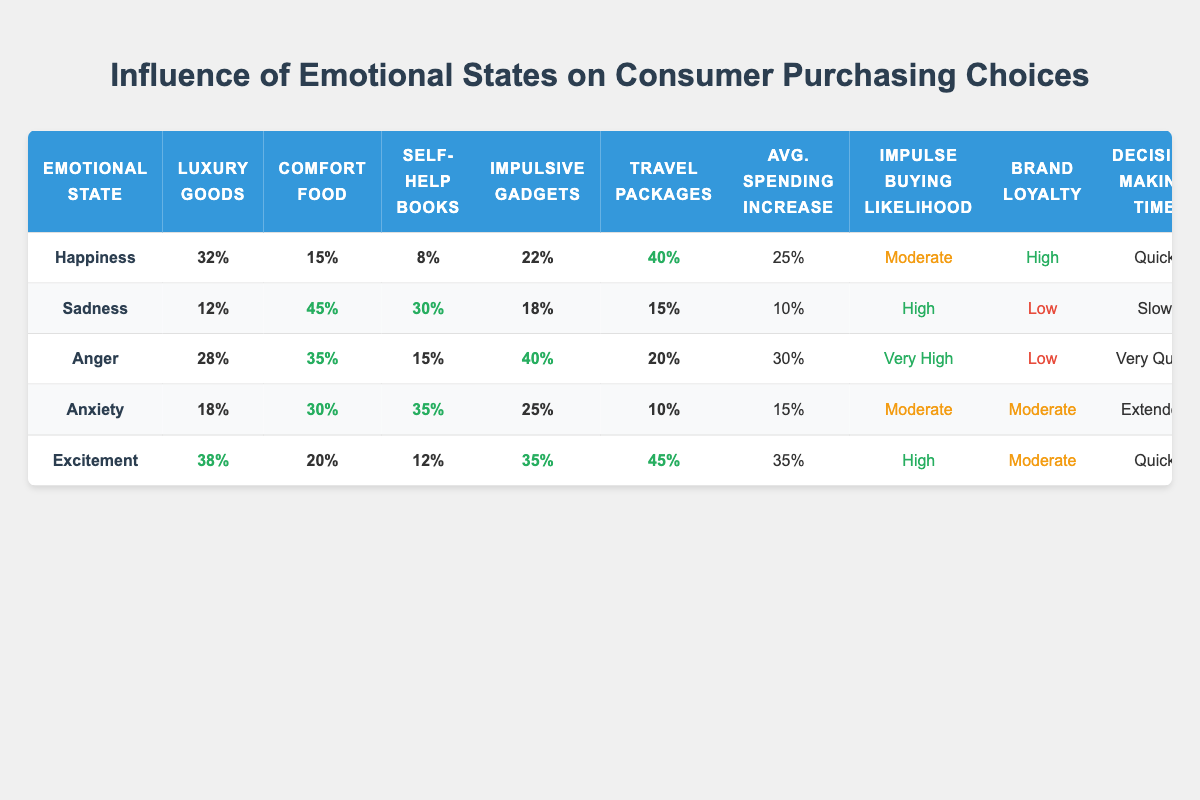What is the purchase percentage for luxury goods when the emotional state is happiness? The purchase percentage for luxury goods under the emotional state of happiness is found in the corresponding row of the table. It indicates that 32% of consumers in this emotional state purchase luxury goods.
Answer: 32% Which emotional state resulted in the highest purchase percentage for comfort food? To find this, we look through the comfort food column for each emotional state. Sadness has the highest percentage at 45%, which is more than any other emotional state listed.
Answer: Sadness What is the average spending increase when consumers are in an excited emotional state compared to when they are sad? The average spending increase for excitement is 35% and for sadness is 10%. To find the difference, we subtract 10% from 35%, which gives us 25%.
Answer: 25% Is impulse buying likelihood low for consumers feeling anger? From the table, under the emotional state of anger, the impulse buying likelihood is marked as "Very High," indicating that it is not low. Thus, the answer to this question is no.
Answer: No Which emotional state has the quickest decision-making time, and what is the decision-making time for that state? The emotional states of happiness and anger both have quick and very quick decision-making times respectively. Comparing these two, anger has the quickest time, which is "Very Quick" as per the data.
Answer: Anger, Very Quick What percentage of consumers purchase impulsive gadgets when they are in a state of anxiety? Looking at the anxiety row, the corresponding column for impulsive gadgets shows that 25% of consumers purchase these gadgets.
Answer: 25% In terms of brand loyalty, how does excitement compare with sadness? Excitement has a moderate brand loyalty rating, while sadness has a low rating. This indicates that consumers under excitement are generally more loyal to brands than those under sadness.
Answer: Excitement is higher than sadness What is the total percentage of luxury goods and travel package purchases by consumers in a state of anger? For anger, the purchase percentage of luxury goods is 28% and for travel packages, it is 20%. Adding these together gives 28% + 20% = 48%.
Answer: 48% How does the impulse buying likelihood in a state of anxiety compare to the likelihood in a state of happiness? The impulse buying likelihood in anxiety is moderate, while in happiness it is also moderate. Therefore, there’s no difference; both emotional states yield the same likelihood.
Answer: They are the same 